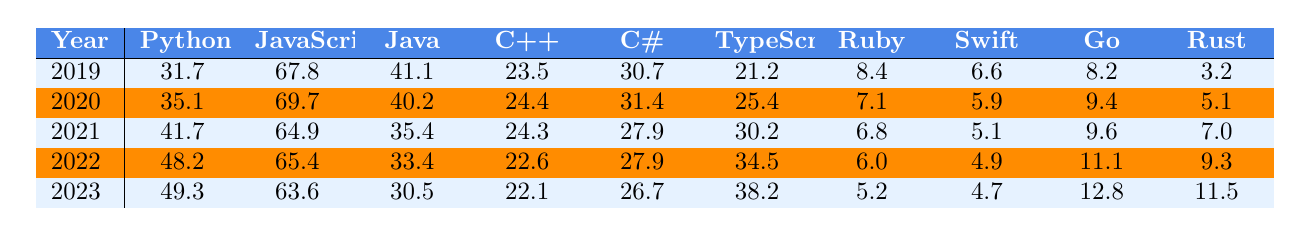What was the popularity of Python in 2021? Referring to the table, the value under the "Python" column for the year 2021 is 41.7.
Answer: 41.7 Which programming language had the highest popularity in 2019? In 2019, the highest value in the "Year" row corresponds to JavaScript, which is 67.8.
Answer: JavaScript What is the difference in popularity between Java and C++ in 2022? The value for Java in 2022 is 33.4, and for C++, it is 22.6. The difference is 33.4 - 22.6 = 10.8.
Answer: 10.8 What was the average popularity of Ruby from 2019 to 2023? The values for Ruby are 8.4, 7.1, 6.8, 6.0, and 5.2. Their total is 33.5, and dividing this by 5 gives an average of 6.7.
Answer: 6.7 Did the popularity of C# increase or decrease from 2020 to 2023? The value for C# in 2020 is 31.4, and in 2023, it is 26.7. Since 26.7 is less than 31.4, it shows a decrease.
Answer: Decrease Which programming language had the most significant increase in popularity from 2019 to 2023? Calculating the differences: Python increased from 31.7 to 49.3 (17.6), JavaScript decreased from 67.8 to 63.6 (-4.2), Java from 41.1 to 30.5 (-10.6), C++ from 23.5 to 22.1 (-1.4), C# from 30.7 to 26.7 (-4.0), TypeScript from 21.2 to 38.2 (17.0), Ruby from 8.4 to 5.2 (-3.2), Swift from 6.6 to 4.7 (-1.9), Go from 8.2 to 12.8 (4.6), and Rust from 3.2 to 11.5 (8.3). The largest increase is for Python (17.6).
Answer: Python What was the popularity of Java in the year with the lowest value? Looking at the table, the lowest value for Java occurs in 2023, which is 30.5.
Answer: 30.5 In which year did TypeScript exceed 30 in popularity? Checking the values, TypeScript first exceeds 30 in the year 2021, where it has a value of 30.2.
Answer: 2021 Is the popularity of Go consistently increasing over the years? Looking at the values for Go: 8.2 (2019), 9.4 (2020), 9.6 (2021), 11.1 (2022), and 12.8 (2023), we can see it increases every year.
Answer: Yes What was the total popularity of all languages in 2022? Adding up all values for 2022: 48.2 (Python) + 65.4 (JavaScript) + 33.4 (Java) + 22.6 (C++) + 27.9 (C#) + 34.5 (TypeScript) + 6.0 (Ruby) + 4.9 (Swift) + 11.1 (Go) + 9.3 (Rust) gives a total of 263.
Answer: 263 